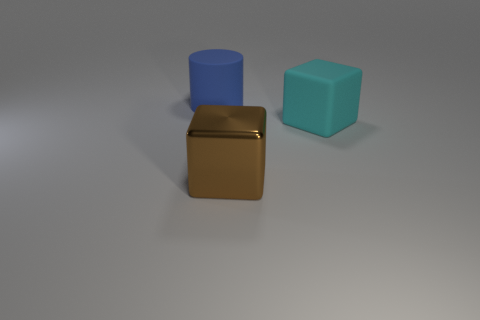Add 2 big brown objects. How many objects exist? 5 Subtract all blocks. How many objects are left? 1 Add 2 metal cubes. How many metal cubes are left? 3 Add 3 large rubber things. How many large rubber things exist? 5 Subtract 0 red blocks. How many objects are left? 3 Subtract all red cylinders. Subtract all green cubes. How many cylinders are left? 1 Subtract all cyan cubes. How many purple cylinders are left? 0 Subtract all large brown metallic things. Subtract all blue objects. How many objects are left? 1 